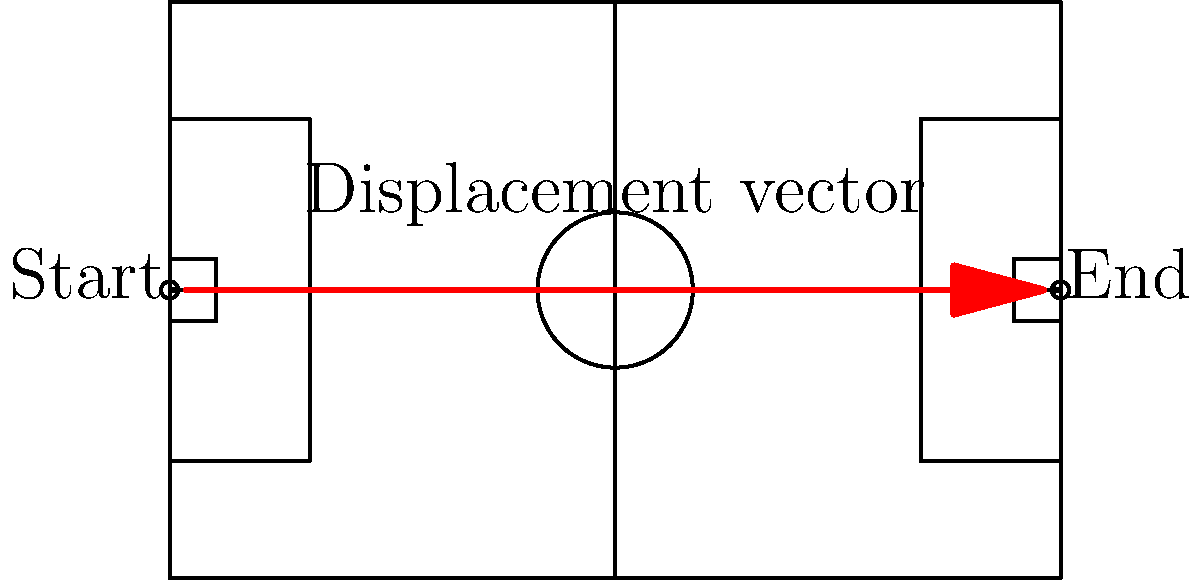A Dinamo Batumi player runs from one end of the field to the other during a counterattack. Given that a standard football field is 105 meters long, what is the magnitude of the displacement vector for this run? To find the magnitude of the displacement vector, we need to follow these steps:

1. Understand the concept of displacement: Displacement is the shortest distance between the initial and final positions, regardless of the actual path taken.

2. Identify the start and end points: In this case, the player starts at one end of the field and finishes at the other end.

3. Determine the length of the field: The question states that a standard football field is 105 meters long.

4. Calculate the displacement: Since the player runs from one end to the other in a straight line (as shown by the red arrow in the diagram), the displacement is equal to the length of the field.

5. Express the answer: The magnitude of the displacement vector is 105 meters.

Note that even if the player didn't run in a perfectly straight line during the counterattack, the displacement would still be 105 meters, as displacement only considers the start and end points.
Answer: 105 meters 